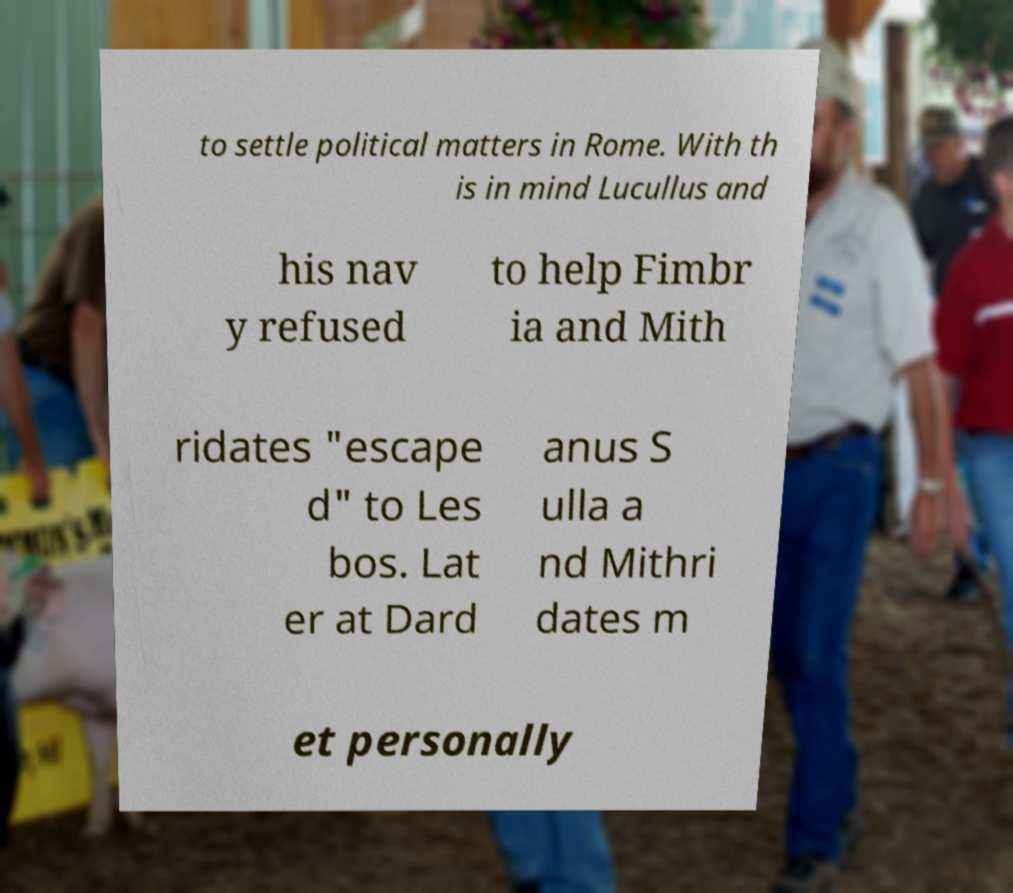Could you assist in decoding the text presented in this image and type it out clearly? to settle political matters in Rome. With th is in mind Lucullus and his nav y refused to help Fimbr ia and Mith ridates "escape d" to Les bos. Lat er at Dard anus S ulla a nd Mithri dates m et personally 